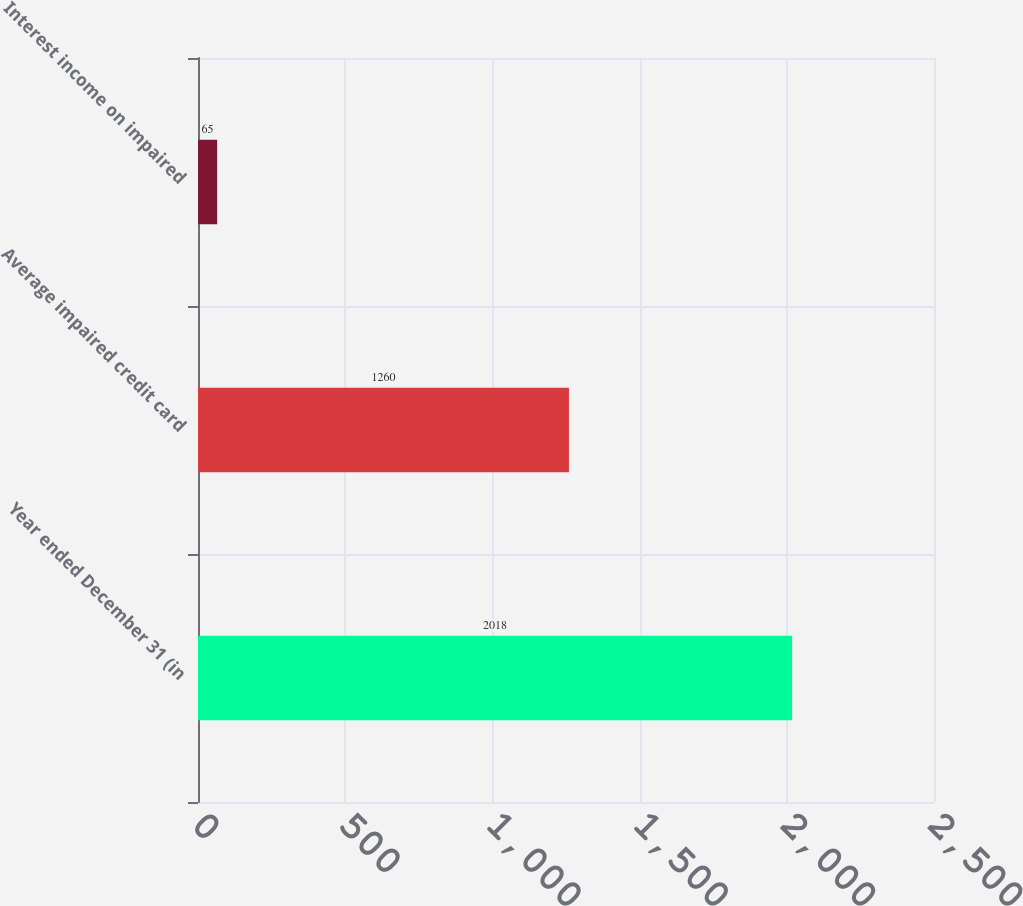Convert chart. <chart><loc_0><loc_0><loc_500><loc_500><bar_chart><fcel>Year ended December 31 (in<fcel>Average impaired credit card<fcel>Interest income on impaired<nl><fcel>2018<fcel>1260<fcel>65<nl></chart> 